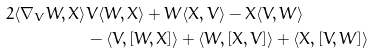<formula> <loc_0><loc_0><loc_500><loc_500>2 \langle \nabla _ { V } W , X \rangle & V \langle W , X \rangle + W \langle X , V \rangle - X \langle V , W \rangle \\ & - \langle V , [ W , X ] \rangle + \langle W , [ X , V ] \rangle + \langle X , [ V , W ] \rangle</formula> 